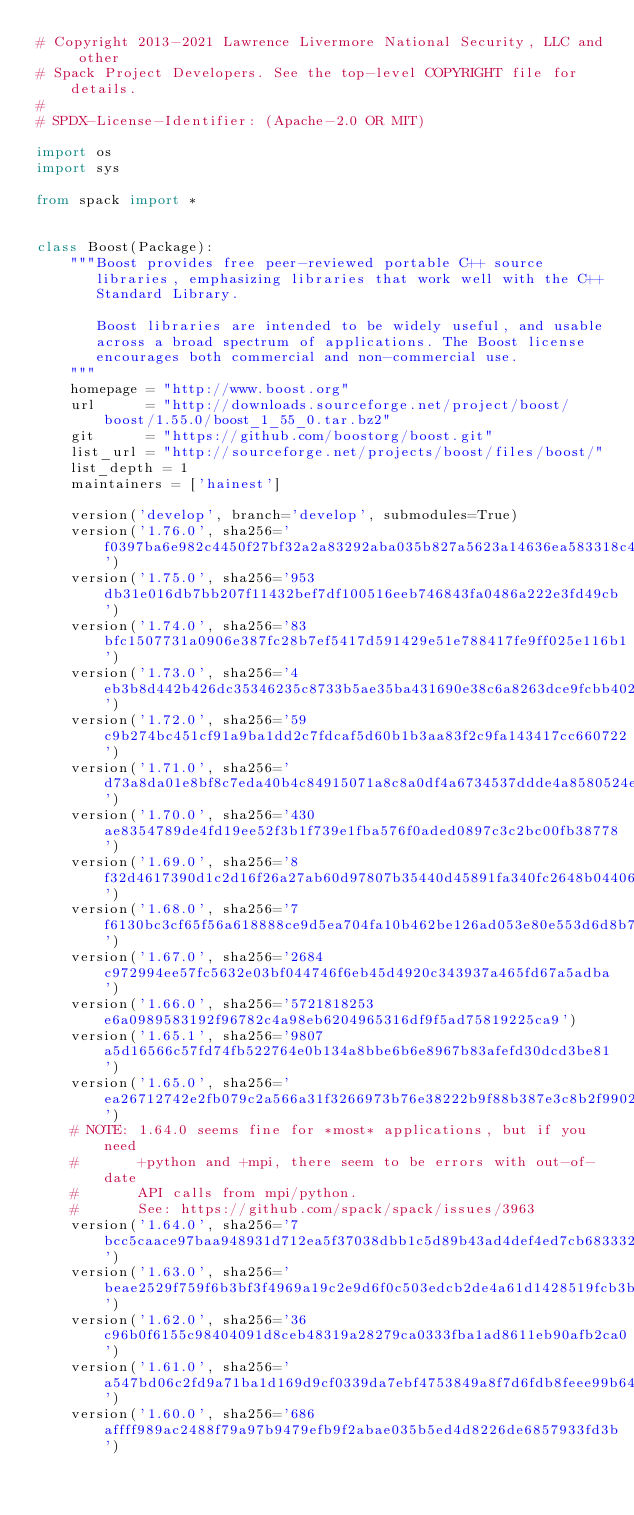<code> <loc_0><loc_0><loc_500><loc_500><_Python_># Copyright 2013-2021 Lawrence Livermore National Security, LLC and other
# Spack Project Developers. See the top-level COPYRIGHT file for details.
#
# SPDX-License-Identifier: (Apache-2.0 OR MIT)

import os
import sys

from spack import *


class Boost(Package):
    """Boost provides free peer-reviewed portable C++ source
       libraries, emphasizing libraries that work well with the C++
       Standard Library.

       Boost libraries are intended to be widely useful, and usable
       across a broad spectrum of applications. The Boost license
       encourages both commercial and non-commercial use.
    """
    homepage = "http://www.boost.org"
    url      = "http://downloads.sourceforge.net/project/boost/boost/1.55.0/boost_1_55_0.tar.bz2"
    git      = "https://github.com/boostorg/boost.git"
    list_url = "http://sourceforge.net/projects/boost/files/boost/"
    list_depth = 1
    maintainers = ['hainest']

    version('develop', branch='develop', submodules=True)
    version('1.76.0', sha256='f0397ba6e982c4450f27bf32a2a83292aba035b827a5623a14636ea583318c41')
    version('1.75.0', sha256='953db31e016db7bb207f11432bef7df100516eeb746843fa0486a222e3fd49cb')
    version('1.74.0', sha256='83bfc1507731a0906e387fc28b7ef5417d591429e51e788417fe9ff025e116b1')
    version('1.73.0', sha256='4eb3b8d442b426dc35346235c8733b5ae35ba431690e38c6a8263dce9fcbb402')
    version('1.72.0', sha256='59c9b274bc451cf91a9ba1dd2c7fdcaf5d60b1b3aa83f2c9fa143417cc660722')
    version('1.71.0', sha256='d73a8da01e8bf8c7eda40b4c84915071a8c8a0df4a6734537ddde4a8580524ee')
    version('1.70.0', sha256='430ae8354789de4fd19ee52f3b1f739e1fba576f0aded0897c3c2bc00fb38778')
    version('1.69.0', sha256='8f32d4617390d1c2d16f26a27ab60d97807b35440d45891fa340fc2648b04406')
    version('1.68.0', sha256='7f6130bc3cf65f56a618888ce9d5ea704fa10b462be126ad053e80e553d6d8b7')
    version('1.67.0', sha256='2684c972994ee57fc5632e03bf044746f6eb45d4920c343937a465fd67a5adba')
    version('1.66.0', sha256='5721818253e6a0989583192f96782c4a98eb6204965316df9f5ad75819225ca9')
    version('1.65.1', sha256='9807a5d16566c57fd74fb522764e0b134a8bbe6b6e8967b83afefd30dcd3be81')
    version('1.65.0', sha256='ea26712742e2fb079c2a566a31f3266973b76e38222b9f88b387e3c8b2f9902c')
    # NOTE: 1.64.0 seems fine for *most* applications, but if you need
    #       +python and +mpi, there seem to be errors with out-of-date
    #       API calls from mpi/python.
    #       See: https://github.com/spack/spack/issues/3963
    version('1.64.0', sha256='7bcc5caace97baa948931d712ea5f37038dbb1c5d89b43ad4def4ed7cb683332')
    version('1.63.0', sha256='beae2529f759f6b3bf3f4969a19c2e9d6f0c503edcb2de4a61d1428519fcb3b0')
    version('1.62.0', sha256='36c96b0f6155c98404091d8ceb48319a28279ca0333fba1ad8611eb90afb2ca0')
    version('1.61.0', sha256='a547bd06c2fd9a71ba1d169d9cf0339da7ebf4753849a8f7d6fdb8feee99b640')
    version('1.60.0', sha256='686affff989ac2488f79a97b9479efb9f2abae035b5ed4d8226de6857933fd3b')</code> 